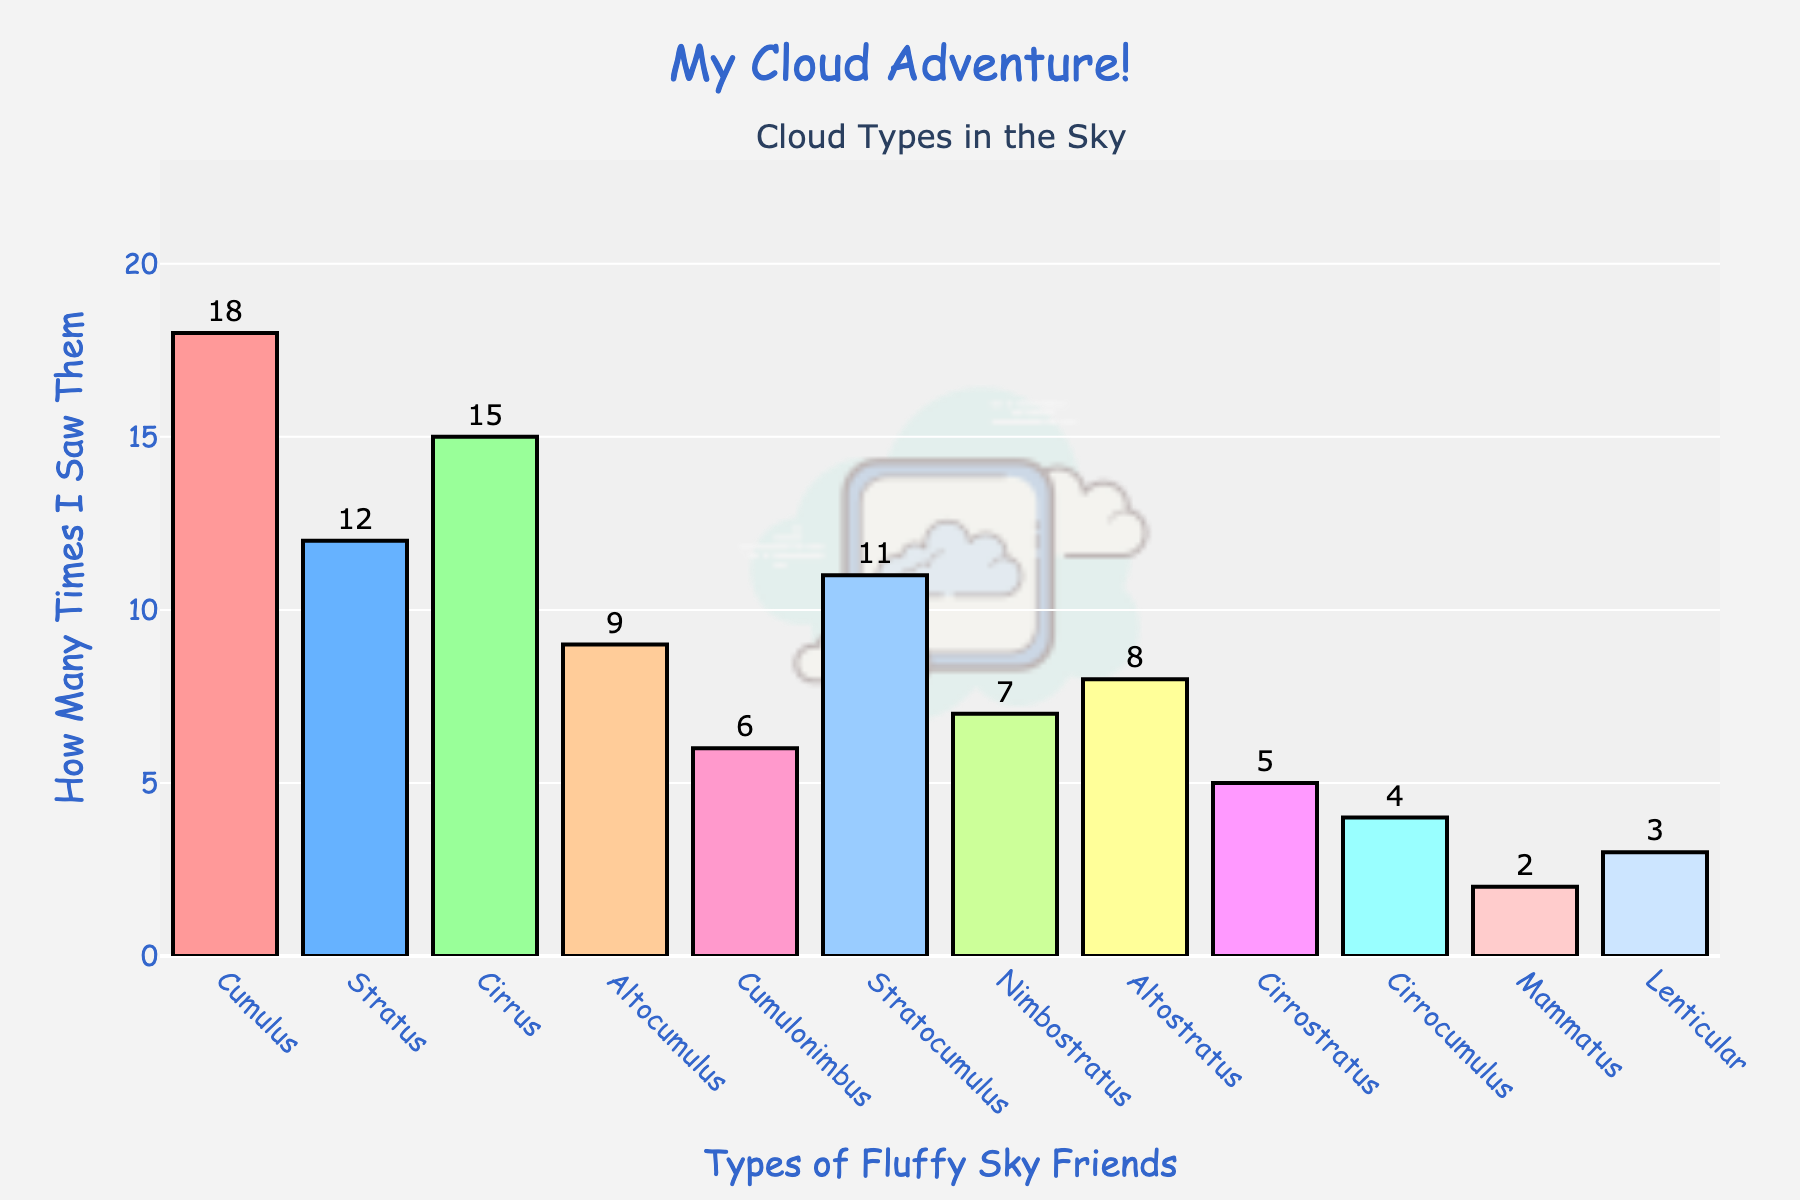What's the most frequently observed cloud type? We can see which bar is the tallest in the chart, which represents the cloud type seen the most. The tallest bar is for "Cumulus," with a frequency of 18.
Answer: Cumulus Which cloud type was observed the least? By looking at the shortest bar in the chart, we can see that the "Mammatus" cloud has the smallest frequency, with a value of 2.
Answer: Mammatus How many more times were Cumulus clouds seen compared to Lenticular clouds? Comparing the heights of the bars for "Cumulus" and "Lenticular," we see that Cumulus was seen 18 times and Lenticular 3 times. The difference is 18 - 3 = 15.
Answer: 15 What is the total number of cloud observations recorded? Summing up the frequencies of all cloud types: 18 (Cumulus) + 12 (Stratus) + 15 (Cirrus) + 9 (Altocumulus) + 6 (Cumulonimbus) + 11 (Stratocumulus) + 7 (Nimbostratus) + 8 (Altostratus) + 5 (Cirrostratus) + 4 (Cirrocumulus) + 2 (Mammatus) + 3 (Lenticular) = 100.
Answer: 100 Which cloud types have more than ten observations? Any bar that extends above the 10 mark on the frequency axis represents cloud types observed more than ten times. These are "Cumulus" (18), "Stratus" (12), and "Cirrus" (15).
Answer: Cumulus, Stratus, Cirrus What is the average number of observations per cloud type? To find the average, we sum the frequencies and divide by the number of cloud types: 100 total observations / 12 cloud types = 8.33 (rounded to two decimal places).
Answer: 8.33 Between Altocumulus and Altostratus, which cloud was observed more frequently? By comparing the bars for "Altocumulus" and "Altostratus," we see that "Altocumulus" has a frequency of 9 and "Altostratus" has 8. So, Altocumulus was observed more.
Answer: Altocumulus What is the combined frequency of Stratus and Cirrus clouds? Adding the frequencies of "Stratus" (12) and "Cirrus" (15) gives us 12 + 15 = 27.
Answer: 27 How many cloud types have fewer than 8 observations each? By counting the bars that do not reach the 8-mark on the y-axis, we find that "Cirrostratus" (5), "Cirrocumulus" (4), "Mammatus" (2), and "Lenticular" (3) meet this criteria, totaling four cloud types.
Answer: 4 Which cloud types have exactly the same number of observations? By checking for bars of equal height, we see that no two cloud types have the same frequency in the chart.
Answer: None 